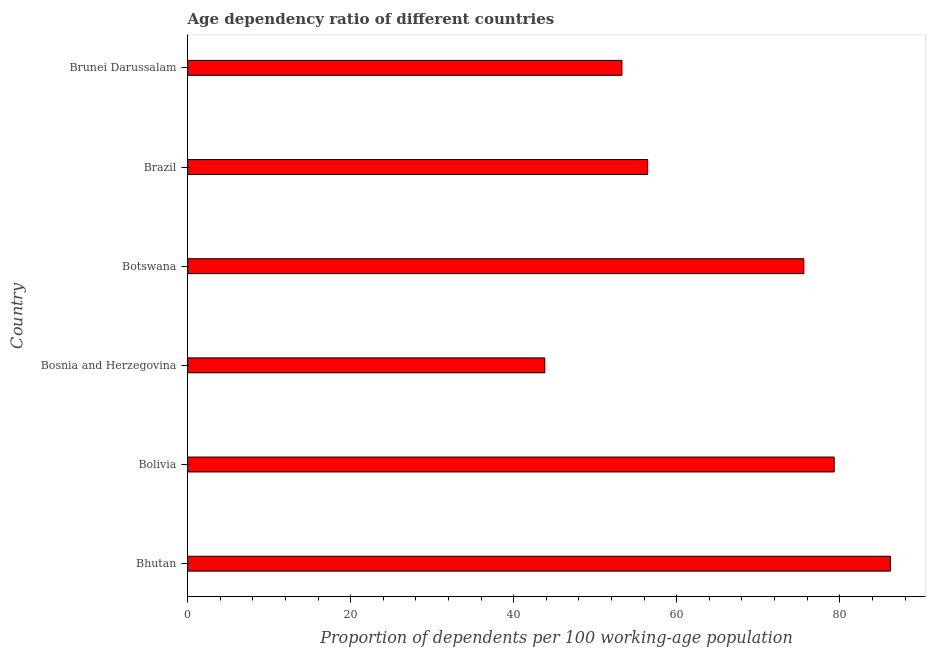Does the graph contain any zero values?
Give a very brief answer. No. Does the graph contain grids?
Give a very brief answer. No. What is the title of the graph?
Provide a succinct answer. Age dependency ratio of different countries. What is the label or title of the X-axis?
Your answer should be compact. Proportion of dependents per 100 working-age population. What is the age dependency ratio in Bolivia?
Offer a terse response. 79.31. Across all countries, what is the maximum age dependency ratio?
Offer a terse response. 86.2. Across all countries, what is the minimum age dependency ratio?
Offer a very short reply. 43.81. In which country was the age dependency ratio maximum?
Ensure brevity in your answer.  Bhutan. In which country was the age dependency ratio minimum?
Give a very brief answer. Bosnia and Herzegovina. What is the sum of the age dependency ratio?
Offer a very short reply. 394.61. What is the difference between the age dependency ratio in Bolivia and Botswana?
Give a very brief answer. 3.73. What is the average age dependency ratio per country?
Provide a succinct answer. 65.77. What is the median age dependency ratio?
Your answer should be compact. 66.01. In how many countries, is the age dependency ratio greater than 52 ?
Your answer should be very brief. 5. What is the ratio of the age dependency ratio in Botswana to that in Brazil?
Offer a very short reply. 1.34. Is the age dependency ratio in Bosnia and Herzegovina less than that in Brunei Darussalam?
Give a very brief answer. Yes. Is the difference between the age dependency ratio in Brazil and Brunei Darussalam greater than the difference between any two countries?
Ensure brevity in your answer.  No. What is the difference between the highest and the second highest age dependency ratio?
Give a very brief answer. 6.89. What is the difference between the highest and the lowest age dependency ratio?
Your response must be concise. 42.39. Are all the bars in the graph horizontal?
Offer a very short reply. Yes. What is the Proportion of dependents per 100 working-age population of Bhutan?
Give a very brief answer. 86.2. What is the Proportion of dependents per 100 working-age population of Bolivia?
Make the answer very short. 79.31. What is the Proportion of dependents per 100 working-age population in Bosnia and Herzegovina?
Make the answer very short. 43.81. What is the Proportion of dependents per 100 working-age population in Botswana?
Provide a short and direct response. 75.59. What is the Proportion of dependents per 100 working-age population in Brazil?
Ensure brevity in your answer.  56.43. What is the Proportion of dependents per 100 working-age population of Brunei Darussalam?
Your answer should be compact. 53.28. What is the difference between the Proportion of dependents per 100 working-age population in Bhutan and Bolivia?
Offer a very short reply. 6.89. What is the difference between the Proportion of dependents per 100 working-age population in Bhutan and Bosnia and Herzegovina?
Give a very brief answer. 42.39. What is the difference between the Proportion of dependents per 100 working-age population in Bhutan and Botswana?
Your answer should be very brief. 10.61. What is the difference between the Proportion of dependents per 100 working-age population in Bhutan and Brazil?
Provide a short and direct response. 29.78. What is the difference between the Proportion of dependents per 100 working-age population in Bhutan and Brunei Darussalam?
Provide a short and direct response. 32.93. What is the difference between the Proportion of dependents per 100 working-age population in Bolivia and Bosnia and Herzegovina?
Ensure brevity in your answer.  35.5. What is the difference between the Proportion of dependents per 100 working-age population in Bolivia and Botswana?
Your answer should be very brief. 3.73. What is the difference between the Proportion of dependents per 100 working-age population in Bolivia and Brazil?
Your answer should be compact. 22.89. What is the difference between the Proportion of dependents per 100 working-age population in Bolivia and Brunei Darussalam?
Provide a short and direct response. 26.04. What is the difference between the Proportion of dependents per 100 working-age population in Bosnia and Herzegovina and Botswana?
Your answer should be very brief. -31.77. What is the difference between the Proportion of dependents per 100 working-age population in Bosnia and Herzegovina and Brazil?
Provide a short and direct response. -12.61. What is the difference between the Proportion of dependents per 100 working-age population in Bosnia and Herzegovina and Brunei Darussalam?
Your answer should be compact. -9.46. What is the difference between the Proportion of dependents per 100 working-age population in Botswana and Brazil?
Offer a very short reply. 19.16. What is the difference between the Proportion of dependents per 100 working-age population in Botswana and Brunei Darussalam?
Give a very brief answer. 22.31. What is the difference between the Proportion of dependents per 100 working-age population in Brazil and Brunei Darussalam?
Keep it short and to the point. 3.15. What is the ratio of the Proportion of dependents per 100 working-age population in Bhutan to that in Bolivia?
Your answer should be very brief. 1.09. What is the ratio of the Proportion of dependents per 100 working-age population in Bhutan to that in Bosnia and Herzegovina?
Your response must be concise. 1.97. What is the ratio of the Proportion of dependents per 100 working-age population in Bhutan to that in Botswana?
Provide a succinct answer. 1.14. What is the ratio of the Proportion of dependents per 100 working-age population in Bhutan to that in Brazil?
Provide a short and direct response. 1.53. What is the ratio of the Proportion of dependents per 100 working-age population in Bhutan to that in Brunei Darussalam?
Provide a short and direct response. 1.62. What is the ratio of the Proportion of dependents per 100 working-age population in Bolivia to that in Bosnia and Herzegovina?
Keep it short and to the point. 1.81. What is the ratio of the Proportion of dependents per 100 working-age population in Bolivia to that in Botswana?
Your answer should be very brief. 1.05. What is the ratio of the Proportion of dependents per 100 working-age population in Bolivia to that in Brazil?
Your answer should be very brief. 1.41. What is the ratio of the Proportion of dependents per 100 working-age population in Bolivia to that in Brunei Darussalam?
Provide a short and direct response. 1.49. What is the ratio of the Proportion of dependents per 100 working-age population in Bosnia and Herzegovina to that in Botswana?
Provide a short and direct response. 0.58. What is the ratio of the Proportion of dependents per 100 working-age population in Bosnia and Herzegovina to that in Brazil?
Give a very brief answer. 0.78. What is the ratio of the Proportion of dependents per 100 working-age population in Bosnia and Herzegovina to that in Brunei Darussalam?
Ensure brevity in your answer.  0.82. What is the ratio of the Proportion of dependents per 100 working-age population in Botswana to that in Brazil?
Make the answer very short. 1.34. What is the ratio of the Proportion of dependents per 100 working-age population in Botswana to that in Brunei Darussalam?
Your answer should be very brief. 1.42. What is the ratio of the Proportion of dependents per 100 working-age population in Brazil to that in Brunei Darussalam?
Your response must be concise. 1.06. 